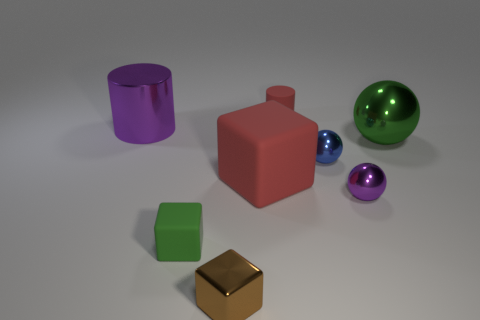Add 1 small yellow matte things. How many objects exist? 9 Subtract all small metallic spheres. How many spheres are left? 1 Subtract 1 balls. How many balls are left? 2 Subtract all blue spheres. How many spheres are left? 2 Subtract all cubes. How many objects are left? 5 Subtract 0 brown balls. How many objects are left? 8 Subtract all blue cubes. Subtract all green cylinders. How many cubes are left? 3 Subtract all large gray rubber cylinders. Subtract all green matte objects. How many objects are left? 7 Add 2 big metallic cylinders. How many big metallic cylinders are left? 3 Add 6 green matte things. How many green matte things exist? 7 